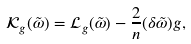<formula> <loc_0><loc_0><loc_500><loc_500>\mathcal { K } _ { g } ( \tilde { \omega } ) = \mathcal { L } _ { g } ( \tilde { \omega } ) - \frac { 2 } { n } ( \delta \tilde { \omega } ) g ,</formula> 